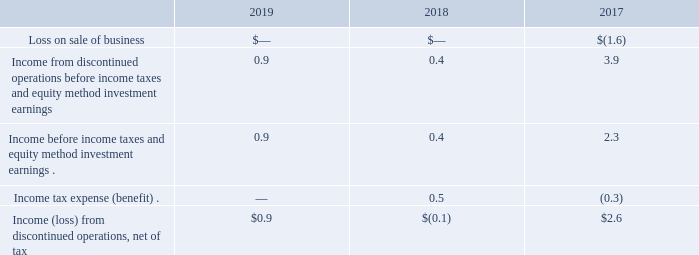Notes to Consolidated Financial Statements - (Continued) Fiscal Years Ended May 26, 2019, May 27, 2018, and May 28, 2017 (columnar dollars in millions except per share amounts) Private Brands Operations
On February 1, 2016, pursuant to the Stock Purchase Agreement, dated as of November 1, 2015, we completed the disposition of our Private Brands operations to TreeHouse Foods, Inc. ("TreeHouse").
The summary comparative financial results of the Private Brands business, included within discontinued operations, were as follows:
We entered into a transition services agreement with TreeHouse and recognized $2.2 million and $16.9 million of income for the performance of services during fiscal 2018 and 2017, respectively, classified within SG&A expenses.
When did the company complete the disposition of their Private Brands operations to TreeHouse Foods, Inc.?  February 1, 2016. What were the incomes before income taxes and equity method investment earnings in the fiscal years 2017 and 2018, respectively?
Answer scale should be: million. 2.3, 0.4. What was the income tax expense (benefit), in millions, in the fiscal year 2018? 0.5. What is the ratio of income  from discontinued operations (net of tax) to income for the performance of services (classified within SG&A expenses) during fiscal 2017? 2.6/16.9 
Answer: 0.15. What is the percentage change in income from discontinued operations (net of tax) from 2017 to 2019?
Answer scale should be: percent. (0.9-2.6)/2.6 
Answer: -65.38. What is the proportion of income tax benefit over income from discontinued operations during the fiscal year 2017? 0.3/2.6 
Answer: 0.12. 